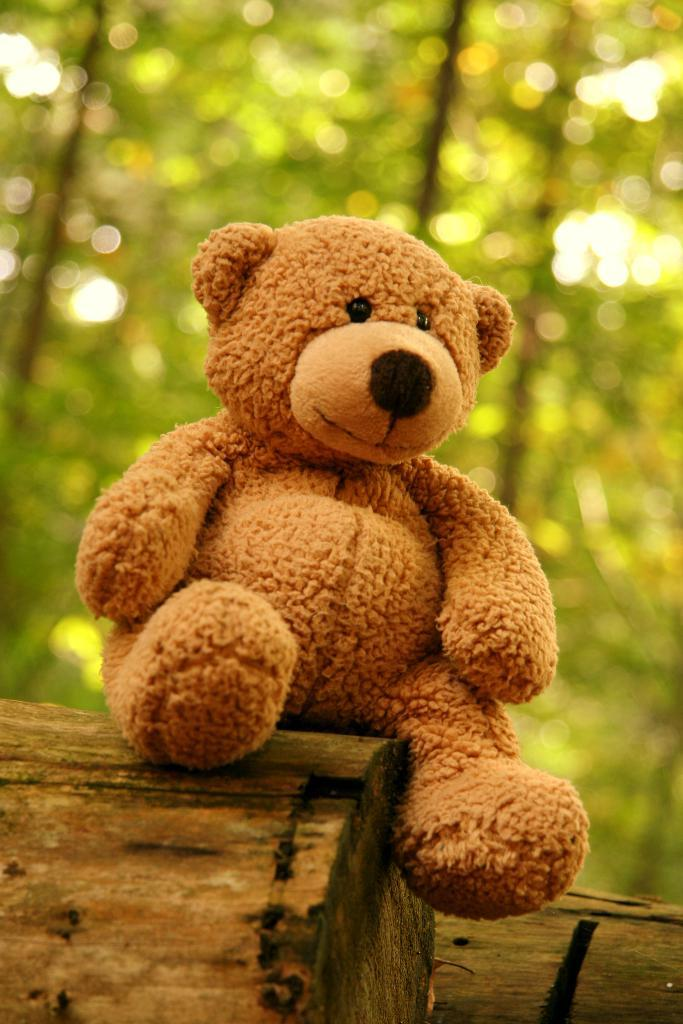What type of doll is in the image? There is a teddy bear doll in the image. What color is the teddy bear doll? The teddy bear doll is brown in color. Where is the teddy bear doll placed in the image? The teddy bear doll is placed on a tree plank. What can be seen in the background of the image? There are trees visible in the background of the image. What type of stew is being served on the chin of the teddy bear doll in the image? There is no stew or chin present on the teddy bear doll in the image. 